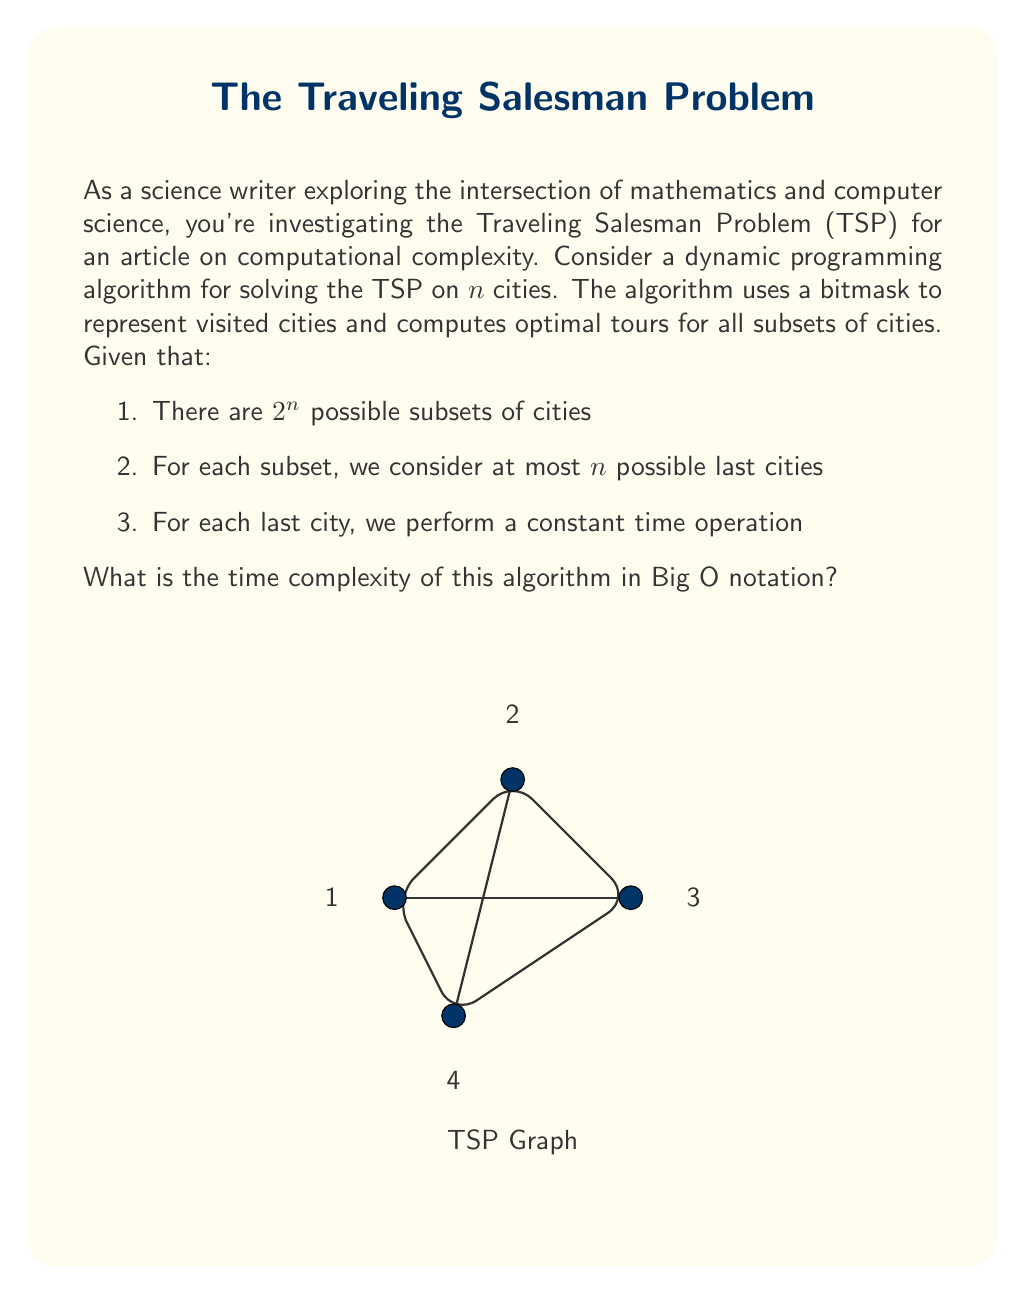Help me with this question. Let's break down the analysis step-by-step:

1) First, we need to understand what the algorithm does:
   - It considers all possible subsets of cities.
   - For each subset, it tries all possible last cities.
   - For each last city, it performs a constant time operation.

2) Now, let's count the number of operations:

   a) Number of subsets:
      - There are $2^n$ possible subsets of $n$ cities.
      
   b) For each subset:
      - We consider at most $n$ possible last cities.
      
   c) For each last city:
      - We perform a constant time operation, let's call this $O(1)$.

3) Putting it all together:
   - Total number of operations = $2^n \times n \times O(1)$
   - This simplifies to $O(2^n \times n)$

4) In Big O notation, we keep the term that grows the fastest. Here, $2^n$ grows much faster than $n$ for large $n$, but we keep both as they are multiplied.

5) Therefore, the time complexity is $O(2^n \times n)$.

This algorithm, while more efficient than the naive approach of checking all permutations ($O(n!)$), is still exponential in time complexity, demonstrating why the TSP is considered a hard problem in computational complexity theory.
Answer: $O(2^n \times n)$ 